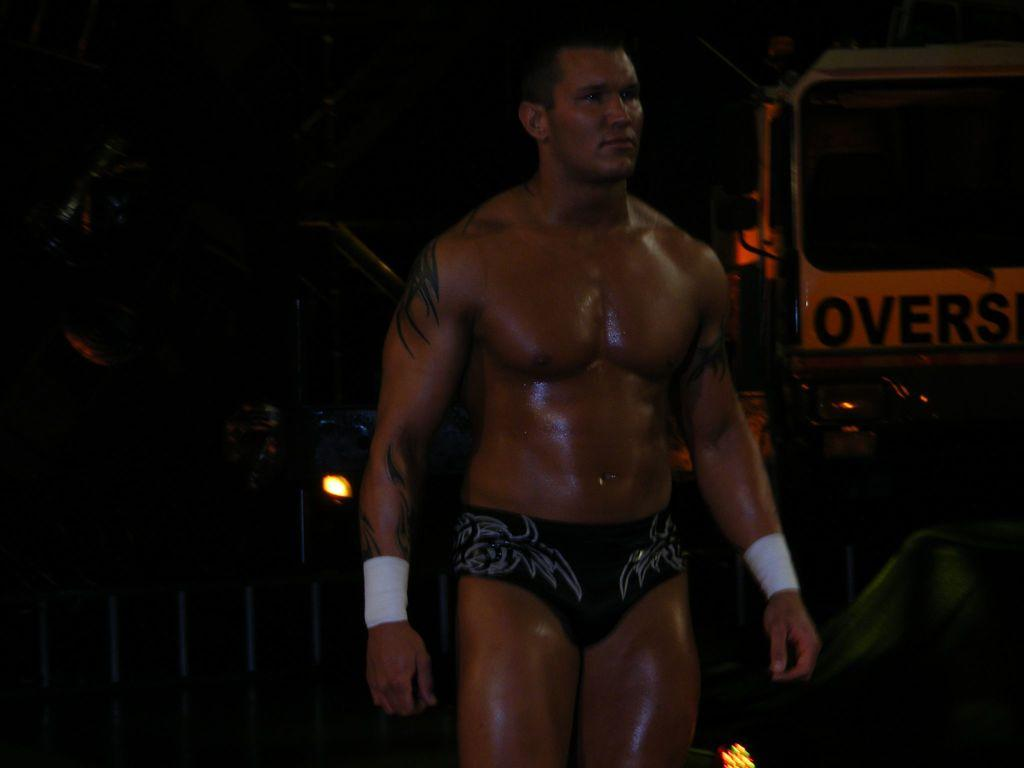What type of person is in the image? There is a bodybuilder in the image. What is the bodybuilder wearing? The bodybuilder is wearing underwear. What is located beside the bodybuilder in the image? The bodybuilder is standing beside a vehicle. What can be observed about the background of the image? The background of the image is dark. What type of root can be seen growing from the bodybuilder's underwear in the image? There is no root growing from the bodybuilder's underwear in the image. How many forks are visible in the image? There are no forks present in the image. 